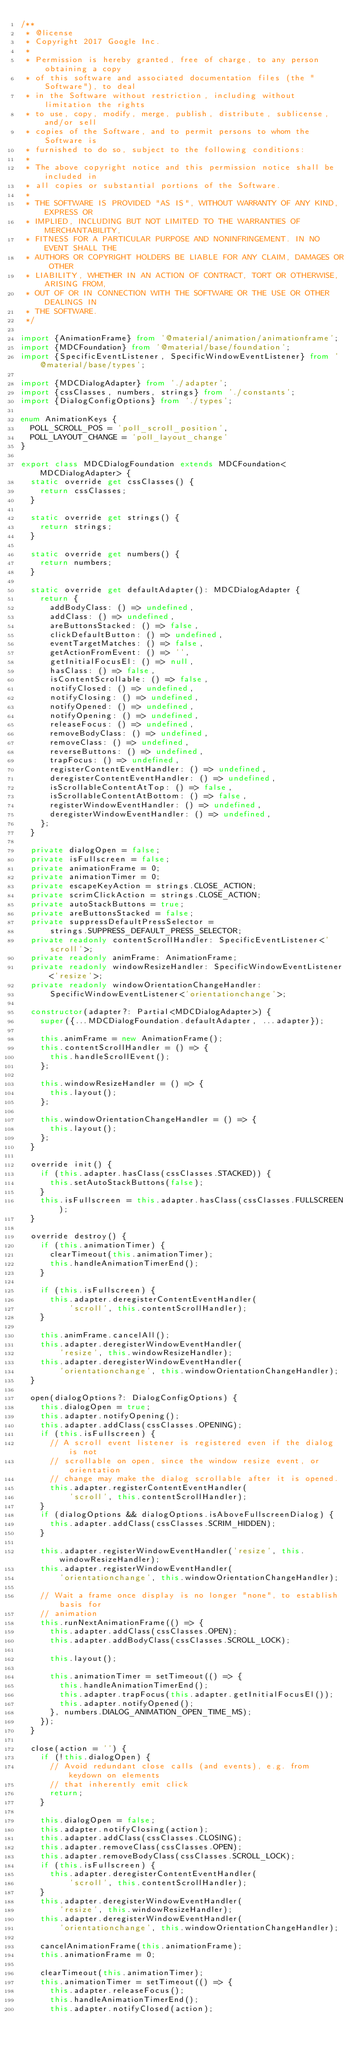<code> <loc_0><loc_0><loc_500><loc_500><_TypeScript_>/**
 * @license
 * Copyright 2017 Google Inc.
 *
 * Permission is hereby granted, free of charge, to any person obtaining a copy
 * of this software and associated documentation files (the "Software"), to deal
 * in the Software without restriction, including without limitation the rights
 * to use, copy, modify, merge, publish, distribute, sublicense, and/or sell
 * copies of the Software, and to permit persons to whom the Software is
 * furnished to do so, subject to the following conditions:
 *
 * The above copyright notice and this permission notice shall be included in
 * all copies or substantial portions of the Software.
 *
 * THE SOFTWARE IS PROVIDED "AS IS", WITHOUT WARRANTY OF ANY KIND, EXPRESS OR
 * IMPLIED, INCLUDING BUT NOT LIMITED TO THE WARRANTIES OF MERCHANTABILITY,
 * FITNESS FOR A PARTICULAR PURPOSE AND NONINFRINGEMENT. IN NO EVENT SHALL THE
 * AUTHORS OR COPYRIGHT HOLDERS BE LIABLE FOR ANY CLAIM, DAMAGES OR OTHER
 * LIABILITY, WHETHER IN AN ACTION OF CONTRACT, TORT OR OTHERWISE, ARISING FROM,
 * OUT OF OR IN CONNECTION WITH THE SOFTWARE OR THE USE OR OTHER DEALINGS IN
 * THE SOFTWARE.
 */

import {AnimationFrame} from '@material/animation/animationframe';
import {MDCFoundation} from '@material/base/foundation';
import {SpecificEventListener, SpecificWindowEventListener} from '@material/base/types';

import {MDCDialogAdapter} from './adapter';
import {cssClasses, numbers, strings} from './constants';
import {DialogConfigOptions} from './types';

enum AnimationKeys {
  POLL_SCROLL_POS = 'poll_scroll_position',
  POLL_LAYOUT_CHANGE = 'poll_layout_change'
}

export class MDCDialogFoundation extends MDCFoundation<MDCDialogAdapter> {
  static override get cssClasses() {
    return cssClasses;
  }

  static override get strings() {
    return strings;
  }

  static override get numbers() {
    return numbers;
  }

  static override get defaultAdapter(): MDCDialogAdapter {
    return {
      addBodyClass: () => undefined,
      addClass: () => undefined,
      areButtonsStacked: () => false,
      clickDefaultButton: () => undefined,
      eventTargetMatches: () => false,
      getActionFromEvent: () => '',
      getInitialFocusEl: () => null,
      hasClass: () => false,
      isContentScrollable: () => false,
      notifyClosed: () => undefined,
      notifyClosing: () => undefined,
      notifyOpened: () => undefined,
      notifyOpening: () => undefined,
      releaseFocus: () => undefined,
      removeBodyClass: () => undefined,
      removeClass: () => undefined,
      reverseButtons: () => undefined,
      trapFocus: () => undefined,
      registerContentEventHandler: () => undefined,
      deregisterContentEventHandler: () => undefined,
      isScrollableContentAtTop: () => false,
      isScrollableContentAtBottom: () => false,
      registerWindowEventHandler: () => undefined,
      deregisterWindowEventHandler: () => undefined,
    };
  }

  private dialogOpen = false;
  private isFullscreen = false;
  private animationFrame = 0;
  private animationTimer = 0;
  private escapeKeyAction = strings.CLOSE_ACTION;
  private scrimClickAction = strings.CLOSE_ACTION;
  private autoStackButtons = true;
  private areButtonsStacked = false;
  private suppressDefaultPressSelector =
      strings.SUPPRESS_DEFAULT_PRESS_SELECTOR;
  private readonly contentScrollHandler: SpecificEventListener<'scroll'>;
  private readonly animFrame: AnimationFrame;
  private readonly windowResizeHandler: SpecificWindowEventListener<'resize'>;
  private readonly windowOrientationChangeHandler:
      SpecificWindowEventListener<'orientationchange'>;

  constructor(adapter?: Partial<MDCDialogAdapter>) {
    super({...MDCDialogFoundation.defaultAdapter, ...adapter});

    this.animFrame = new AnimationFrame();
    this.contentScrollHandler = () => {
      this.handleScrollEvent();
    };

    this.windowResizeHandler = () => {
      this.layout();
    };

    this.windowOrientationChangeHandler = () => {
      this.layout();
    };
  }

  override init() {
    if (this.adapter.hasClass(cssClasses.STACKED)) {
      this.setAutoStackButtons(false);
    }
    this.isFullscreen = this.adapter.hasClass(cssClasses.FULLSCREEN);
  }

  override destroy() {
    if (this.animationTimer) {
      clearTimeout(this.animationTimer);
      this.handleAnimationTimerEnd();
    }

    if (this.isFullscreen) {
      this.adapter.deregisterContentEventHandler(
          'scroll', this.contentScrollHandler);
    }

    this.animFrame.cancelAll();
    this.adapter.deregisterWindowEventHandler(
        'resize', this.windowResizeHandler);
    this.adapter.deregisterWindowEventHandler(
        'orientationchange', this.windowOrientationChangeHandler);
  }

  open(dialogOptions?: DialogConfigOptions) {
    this.dialogOpen = true;
    this.adapter.notifyOpening();
    this.adapter.addClass(cssClasses.OPENING);
    if (this.isFullscreen) {
      // A scroll event listener is registered even if the dialog is not
      // scrollable on open, since the window resize event, or orientation
      // change may make the dialog scrollable after it is opened.
      this.adapter.registerContentEventHandler(
          'scroll', this.contentScrollHandler);
    }
    if (dialogOptions && dialogOptions.isAboveFullscreenDialog) {
      this.adapter.addClass(cssClasses.SCRIM_HIDDEN);
    }

    this.adapter.registerWindowEventHandler('resize', this.windowResizeHandler);
    this.adapter.registerWindowEventHandler(
        'orientationchange', this.windowOrientationChangeHandler);

    // Wait a frame once display is no longer "none", to establish basis for
    // animation
    this.runNextAnimationFrame(() => {
      this.adapter.addClass(cssClasses.OPEN);
      this.adapter.addBodyClass(cssClasses.SCROLL_LOCK);

      this.layout();

      this.animationTimer = setTimeout(() => {
        this.handleAnimationTimerEnd();
        this.adapter.trapFocus(this.adapter.getInitialFocusEl());
        this.adapter.notifyOpened();
      }, numbers.DIALOG_ANIMATION_OPEN_TIME_MS);
    });
  }

  close(action = '') {
    if (!this.dialogOpen) {
      // Avoid redundant close calls (and events), e.g. from keydown on elements
      // that inherently emit click
      return;
    }

    this.dialogOpen = false;
    this.adapter.notifyClosing(action);
    this.adapter.addClass(cssClasses.CLOSING);
    this.adapter.removeClass(cssClasses.OPEN);
    this.adapter.removeBodyClass(cssClasses.SCROLL_LOCK);
    if (this.isFullscreen) {
      this.adapter.deregisterContentEventHandler(
          'scroll', this.contentScrollHandler);
    }
    this.adapter.deregisterWindowEventHandler(
        'resize', this.windowResizeHandler);
    this.adapter.deregisterWindowEventHandler(
        'orientationchange', this.windowOrientationChangeHandler);

    cancelAnimationFrame(this.animationFrame);
    this.animationFrame = 0;

    clearTimeout(this.animationTimer);
    this.animationTimer = setTimeout(() => {
      this.adapter.releaseFocus();
      this.handleAnimationTimerEnd();
      this.adapter.notifyClosed(action);</code> 